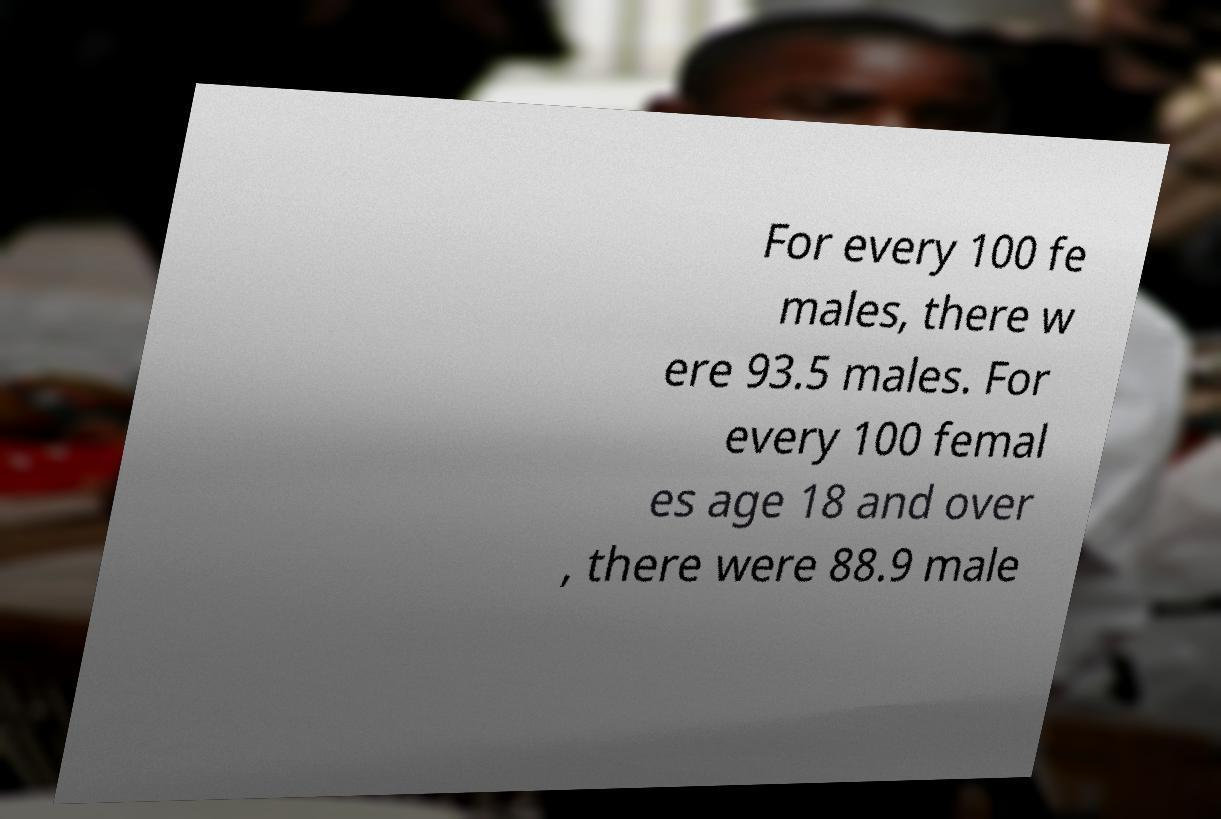Please read and relay the text visible in this image. What does it say? For every 100 fe males, there w ere 93.5 males. For every 100 femal es age 18 and over , there were 88.9 male 